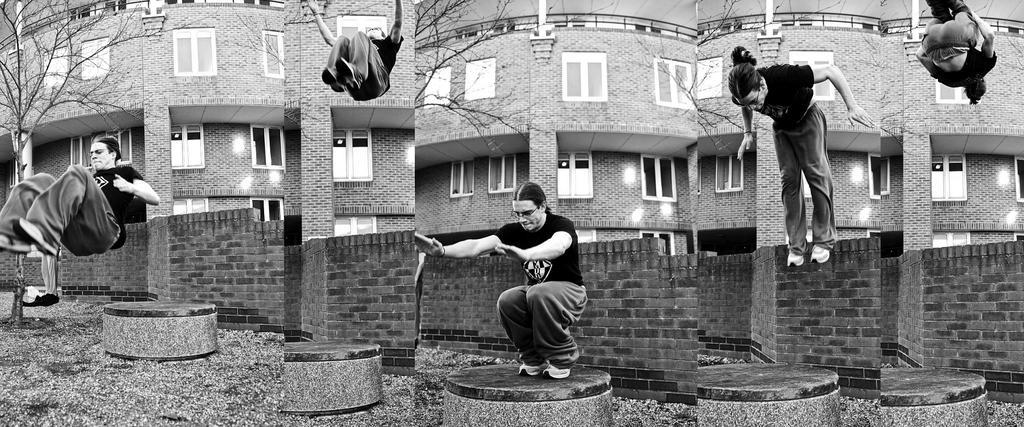What type of image is being described? The image is a collage. Can you describe the man in the image? The man in the image is doing a jumping action. What is behind the man in the image? There is a wall behind the man. What can be seen in the background of the image? There is a tree and a building in the background. What does the man desire in the image? There is no information about the man's desires in the image. How many times has the image been changed since it was created? The image is a collage, but there is no information about how many times it has been changed. 